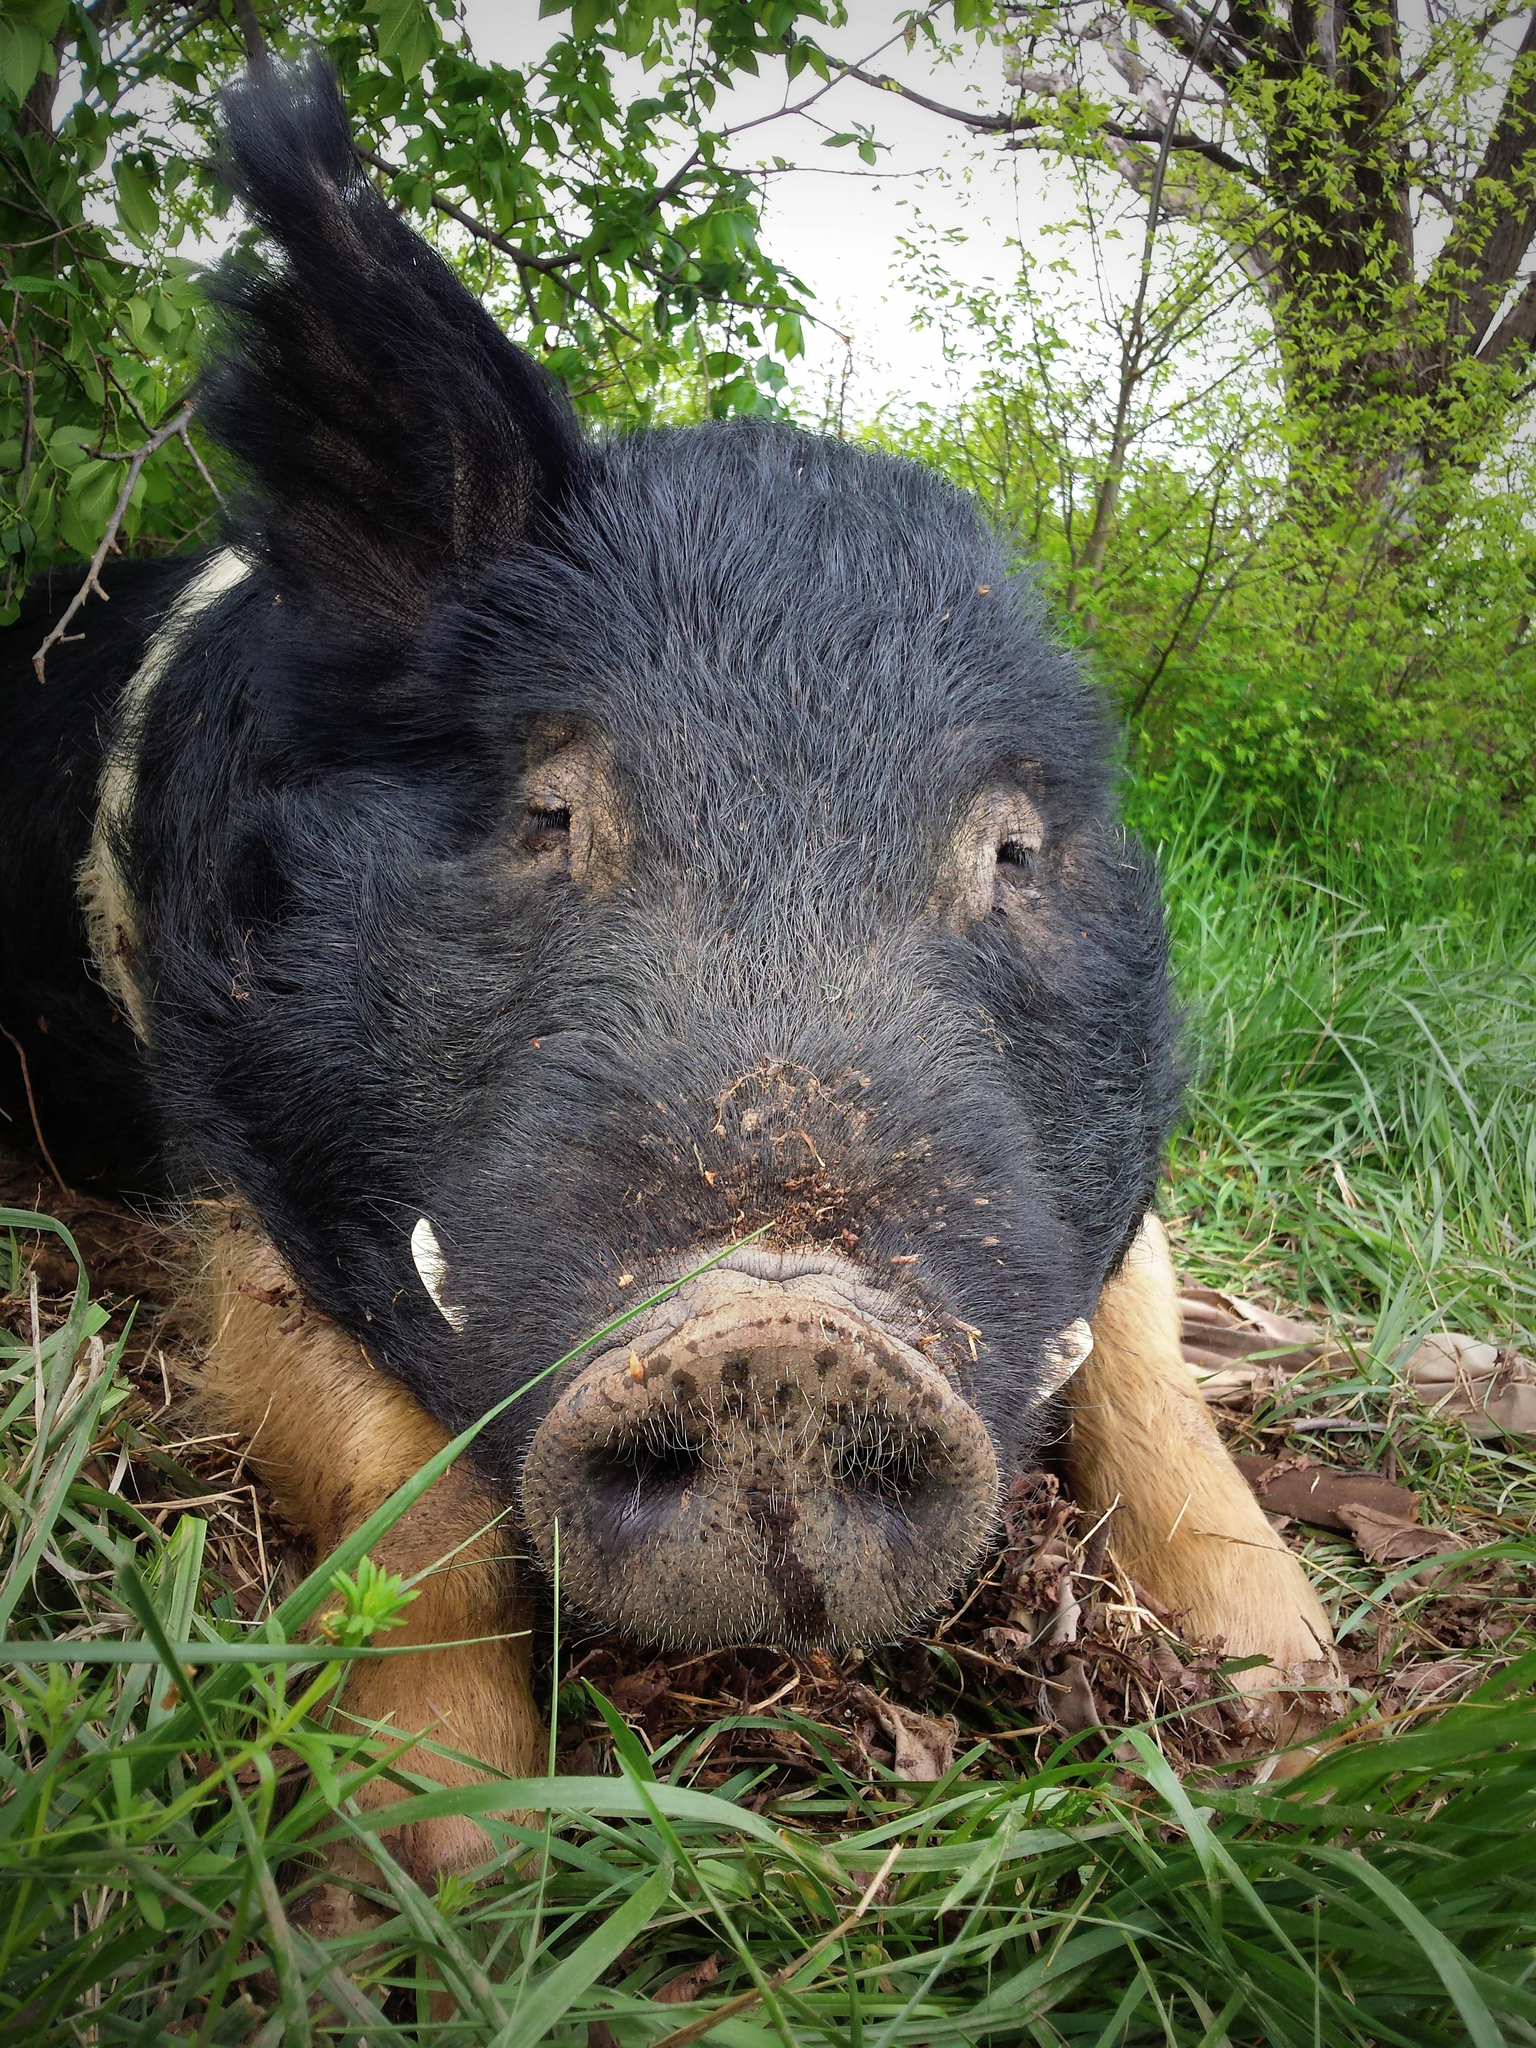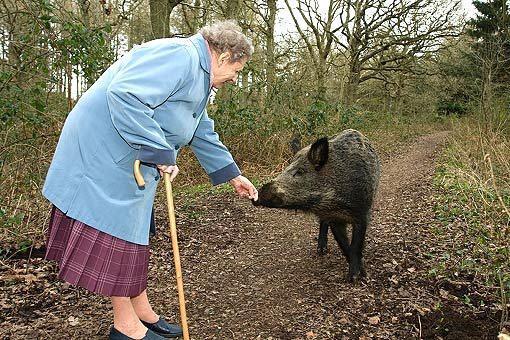The first image is the image on the left, the second image is the image on the right. Considering the images on both sides, is "One image shows at least one hunter posing behind a warthog." valid? Answer yes or no. No. The first image is the image on the left, the second image is the image on the right. Considering the images on both sides, is "An image shows at least one man in a camo hat crouched behind a dead hog lying on the ground with its mouth propped open." valid? Answer yes or no. No. 